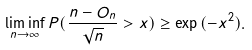<formula> <loc_0><loc_0><loc_500><loc_500>\liminf _ { n \rightarrow \infty } P ( \frac { n - O _ { n } } { \sqrt { n } } > x ) \geq \exp { ( - x ^ { 2 } ) } .</formula> 